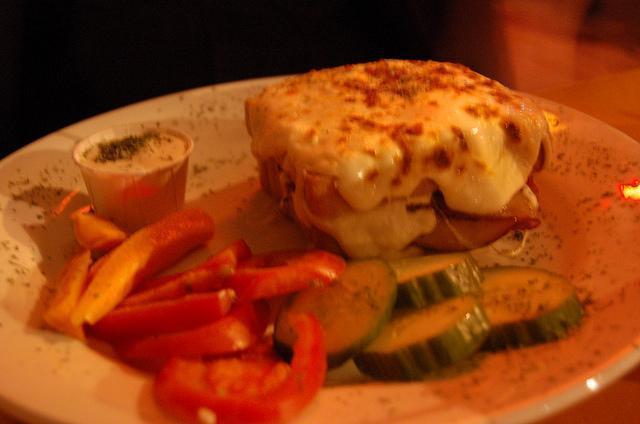How many carrots are visible?
Give a very brief answer. 2. How many motorcycles are in the photo?
Give a very brief answer. 0. 